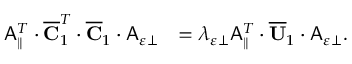Convert formula to latex. <formula><loc_0><loc_0><loc_500><loc_500>\begin{array} { r l } { A _ { \| } ^ { T } \cdot \overline { C } _ { 1 } ^ { T } \cdot \overline { C } _ { 1 } \cdot A _ { \varepsilon \perp } } & { = \lambda _ { \varepsilon \perp } A _ { \| } ^ { T } \cdot \overline { U } _ { 1 } \cdot A _ { \varepsilon \perp } . } \end{array}</formula> 